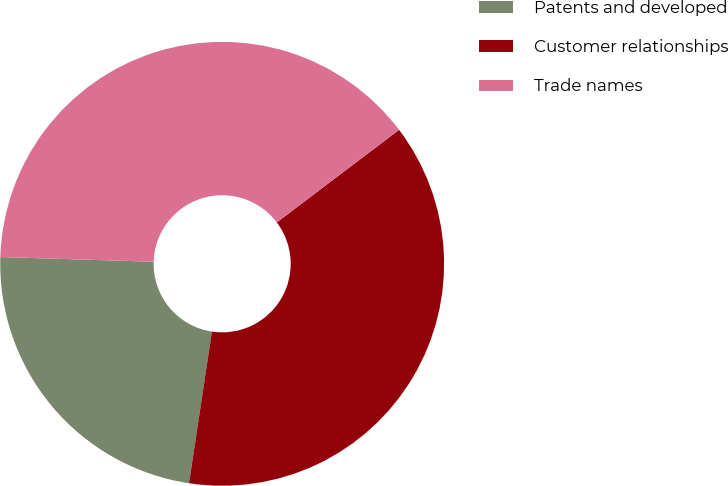Convert chart to OTSL. <chart><loc_0><loc_0><loc_500><loc_500><pie_chart><fcel>Patents and developed<fcel>Customer relationships<fcel>Trade names<nl><fcel>23.1%<fcel>37.7%<fcel>39.2%<nl></chart> 